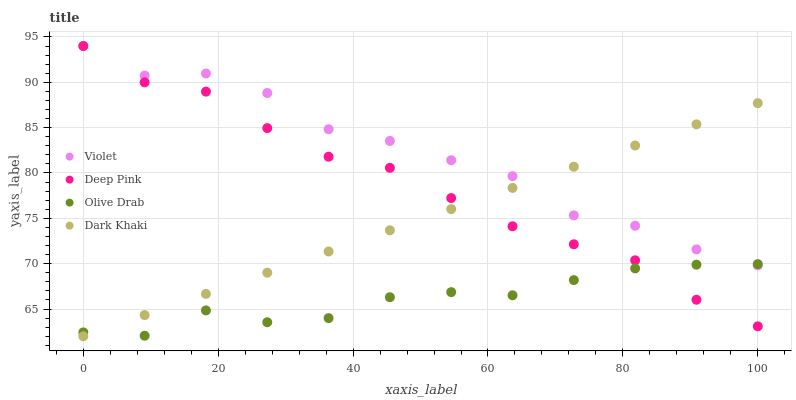Does Olive Drab have the minimum area under the curve?
Answer yes or no. Yes. Does Violet have the maximum area under the curve?
Answer yes or no. Yes. Does Deep Pink have the minimum area under the curve?
Answer yes or no. No. Does Deep Pink have the maximum area under the curve?
Answer yes or no. No. Is Dark Khaki the smoothest?
Answer yes or no. Yes. Is Violet the roughest?
Answer yes or no. Yes. Is Deep Pink the smoothest?
Answer yes or no. No. Is Deep Pink the roughest?
Answer yes or no. No. Does Dark Khaki have the lowest value?
Answer yes or no. Yes. Does Deep Pink have the lowest value?
Answer yes or no. No. Does Violet have the highest value?
Answer yes or no. Yes. Does Olive Drab have the highest value?
Answer yes or no. No. Does Dark Khaki intersect Violet?
Answer yes or no. Yes. Is Dark Khaki less than Violet?
Answer yes or no. No. Is Dark Khaki greater than Violet?
Answer yes or no. No. 